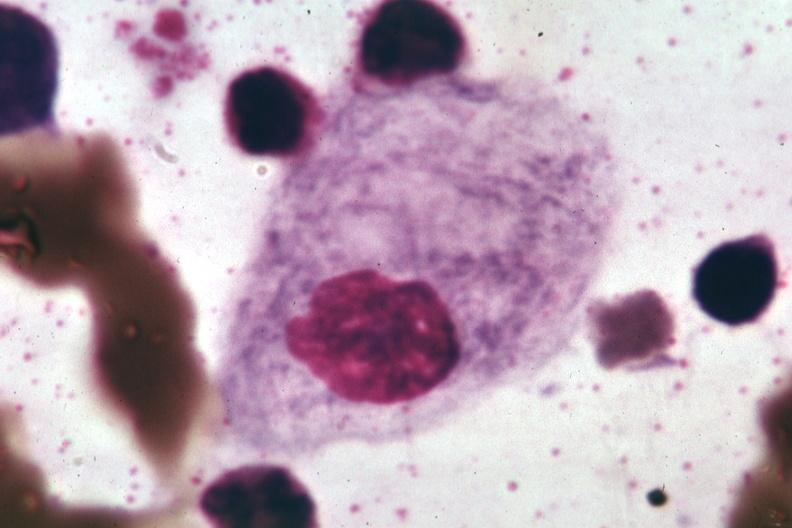does this image show wrights?
Answer the question using a single word or phrase. Yes 